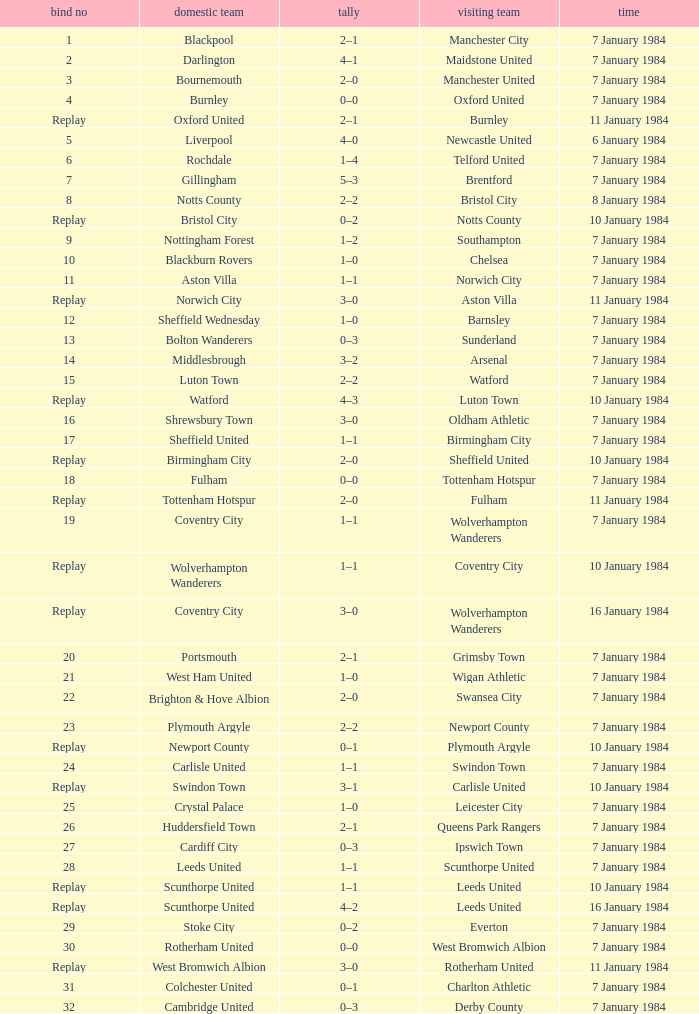Who was the opposing team with a 14-14 tie? Arsenal. 